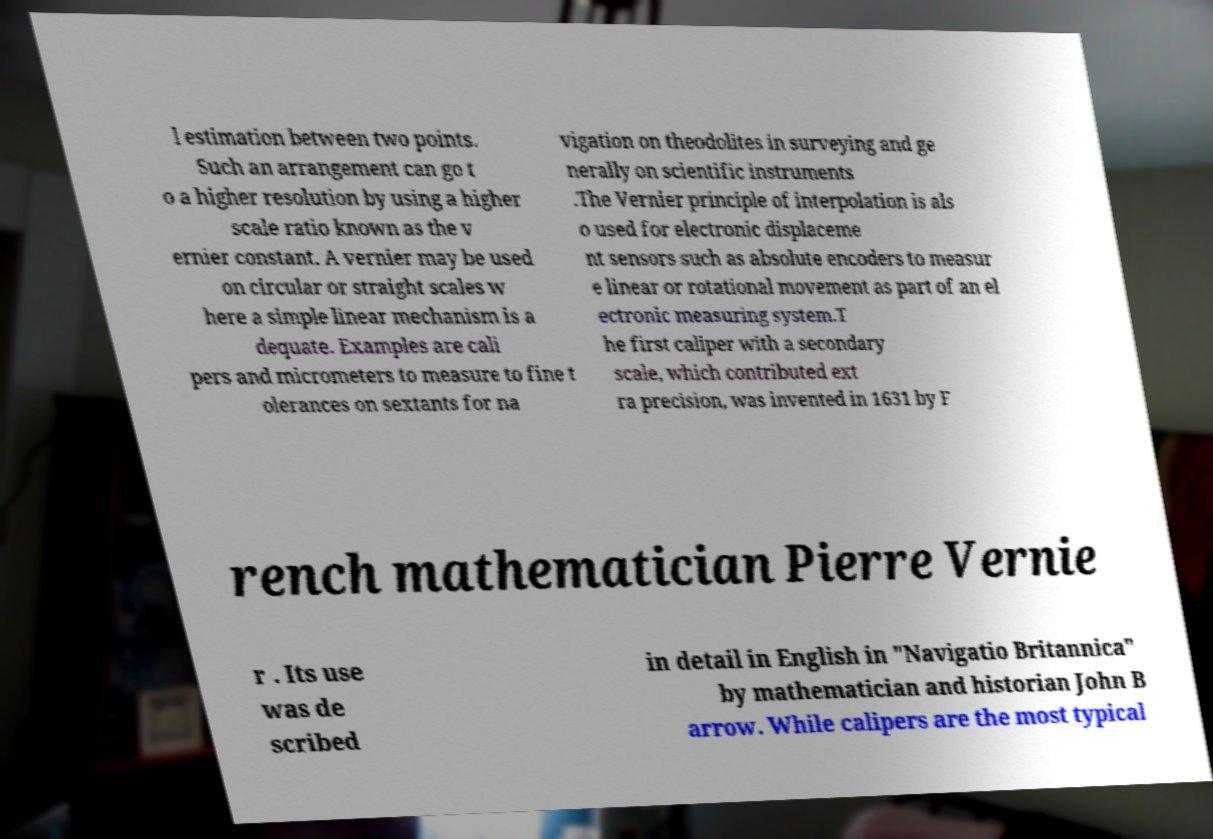Please identify and transcribe the text found in this image. l estimation between two points. Such an arrangement can go t o a higher resolution by using a higher scale ratio known as the v ernier constant. A vernier may be used on circular or straight scales w here a simple linear mechanism is a dequate. Examples are cali pers and micrometers to measure to fine t olerances on sextants for na vigation on theodolites in surveying and ge nerally on scientific instruments .The Vernier principle of interpolation is als o used for electronic displaceme nt sensors such as absolute encoders to measur e linear or rotational movement as part of an el ectronic measuring system.T he first caliper with a secondary scale, which contributed ext ra precision, was invented in 1631 by F rench mathematician Pierre Vernie r . Its use was de scribed in detail in English in "Navigatio Britannica" by mathematician and historian John B arrow. While calipers are the most typical 